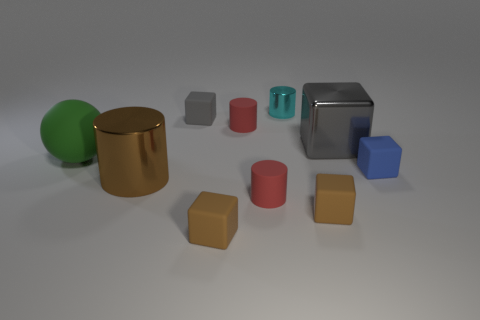Do the cyan object and the brown shiny object have the same shape?
Your answer should be compact. Yes. Are there any other things that are the same shape as the big rubber object?
Give a very brief answer. No. There is a tiny cube that is behind the big green rubber object; is it the same color as the big metal object on the right side of the tiny gray object?
Make the answer very short. Yes. Are there fewer small brown blocks left of the green sphere than red objects in front of the big cylinder?
Keep it short and to the point. Yes. What is the shape of the big metal object that is on the left side of the gray shiny thing?
Offer a terse response. Cylinder. There is a thing that is the same color as the shiny cube; what is its material?
Offer a terse response. Rubber. What number of other things are made of the same material as the tiny gray block?
Offer a very short reply. 6. There is a tiny blue rubber thing; does it have the same shape as the large gray thing right of the small gray cube?
Ensure brevity in your answer.  Yes. What shape is the large brown object that is the same material as the tiny cyan thing?
Offer a terse response. Cylinder. Is the number of gray cubes that are on the right side of the green matte sphere greater than the number of big shiny cylinders behind the small cyan cylinder?
Your answer should be very brief. Yes. 